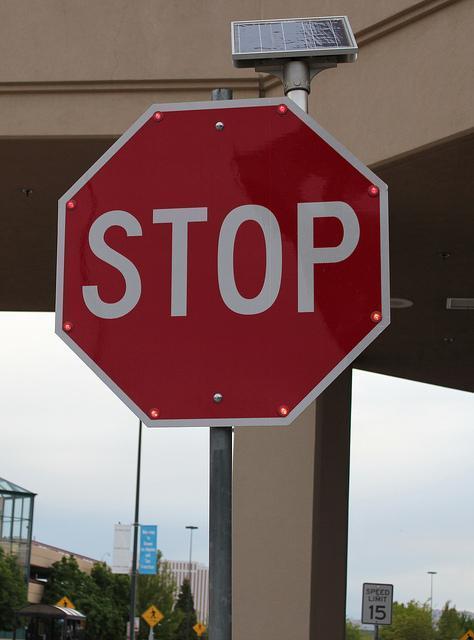How many people are on a horse?
Give a very brief answer. 0. 